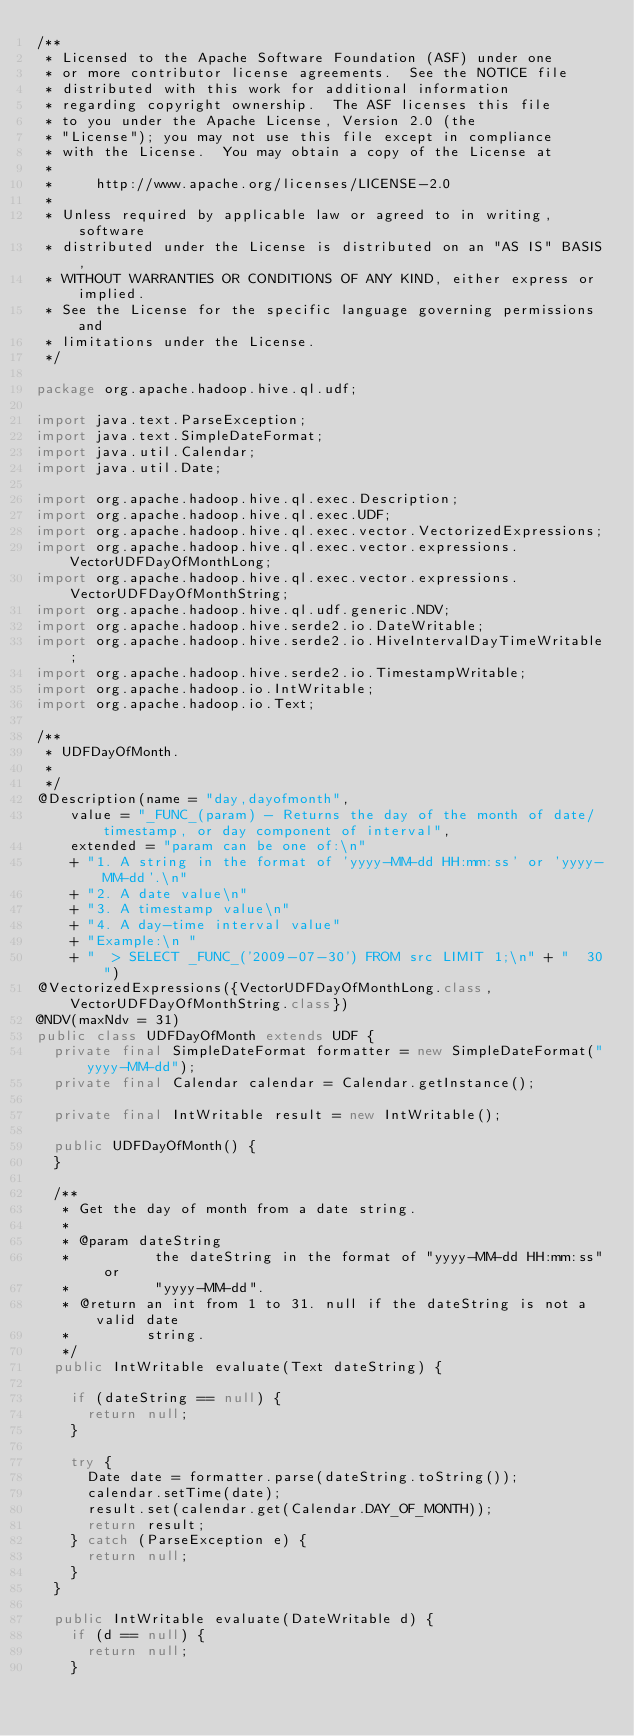Convert code to text. <code><loc_0><loc_0><loc_500><loc_500><_Java_>/**
 * Licensed to the Apache Software Foundation (ASF) under one
 * or more contributor license agreements.  See the NOTICE file
 * distributed with this work for additional information
 * regarding copyright ownership.  The ASF licenses this file
 * to you under the Apache License, Version 2.0 (the
 * "License"); you may not use this file except in compliance
 * with the License.  You may obtain a copy of the License at
 *
 *     http://www.apache.org/licenses/LICENSE-2.0
 *
 * Unless required by applicable law or agreed to in writing, software
 * distributed under the License is distributed on an "AS IS" BASIS,
 * WITHOUT WARRANTIES OR CONDITIONS OF ANY KIND, either express or implied.
 * See the License for the specific language governing permissions and
 * limitations under the License.
 */

package org.apache.hadoop.hive.ql.udf;

import java.text.ParseException;
import java.text.SimpleDateFormat;
import java.util.Calendar;
import java.util.Date;

import org.apache.hadoop.hive.ql.exec.Description;
import org.apache.hadoop.hive.ql.exec.UDF;
import org.apache.hadoop.hive.ql.exec.vector.VectorizedExpressions;
import org.apache.hadoop.hive.ql.exec.vector.expressions.VectorUDFDayOfMonthLong;
import org.apache.hadoop.hive.ql.exec.vector.expressions.VectorUDFDayOfMonthString;
import org.apache.hadoop.hive.ql.udf.generic.NDV;
import org.apache.hadoop.hive.serde2.io.DateWritable;
import org.apache.hadoop.hive.serde2.io.HiveIntervalDayTimeWritable;
import org.apache.hadoop.hive.serde2.io.TimestampWritable;
import org.apache.hadoop.io.IntWritable;
import org.apache.hadoop.io.Text;

/**
 * UDFDayOfMonth.
 *
 */
@Description(name = "day,dayofmonth",
    value = "_FUNC_(param) - Returns the day of the month of date/timestamp, or day component of interval",
    extended = "param can be one of:\n"
    + "1. A string in the format of 'yyyy-MM-dd HH:mm:ss' or 'yyyy-MM-dd'.\n"
    + "2. A date value\n"
    + "3. A timestamp value\n"
    + "4. A day-time interval value"
    + "Example:\n "
    + "  > SELECT _FUNC_('2009-07-30') FROM src LIMIT 1;\n" + "  30")
@VectorizedExpressions({VectorUDFDayOfMonthLong.class, VectorUDFDayOfMonthString.class})
@NDV(maxNdv = 31)
public class UDFDayOfMonth extends UDF {
  private final SimpleDateFormat formatter = new SimpleDateFormat("yyyy-MM-dd");
  private final Calendar calendar = Calendar.getInstance();

  private final IntWritable result = new IntWritable();

  public UDFDayOfMonth() {
  }

  /**
   * Get the day of month from a date string.
   *
   * @param dateString
   *          the dateString in the format of "yyyy-MM-dd HH:mm:ss" or
   *          "yyyy-MM-dd".
   * @return an int from 1 to 31. null if the dateString is not a valid date
   *         string.
   */
  public IntWritable evaluate(Text dateString) {

    if (dateString == null) {
      return null;
    }

    try {
      Date date = formatter.parse(dateString.toString());
      calendar.setTime(date);
      result.set(calendar.get(Calendar.DAY_OF_MONTH));
      return result;
    } catch (ParseException e) {
      return null;
    }
  }

  public IntWritable evaluate(DateWritable d) {
    if (d == null) {
      return null;
    }
</code> 